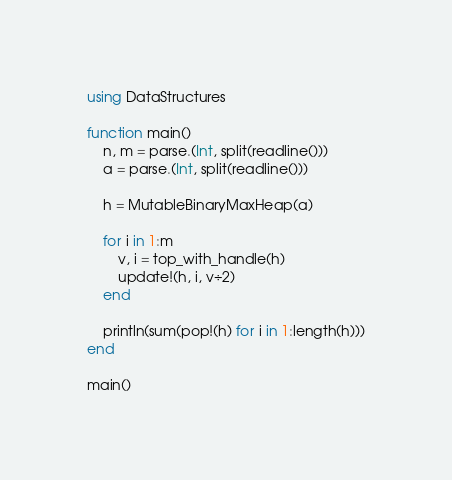<code> <loc_0><loc_0><loc_500><loc_500><_Julia_>using DataStructures

function main()
    n, m = parse.(Int, split(readline()))
    a = parse.(Int, split(readline()))

    h = MutableBinaryMaxHeap(a) 

    for i in 1:m
        v, i = top_with_handle(h)
        update!(h, i, v÷2)
    end

    println(sum(pop!(h) for i in 1:length(h)))
end

main()</code> 